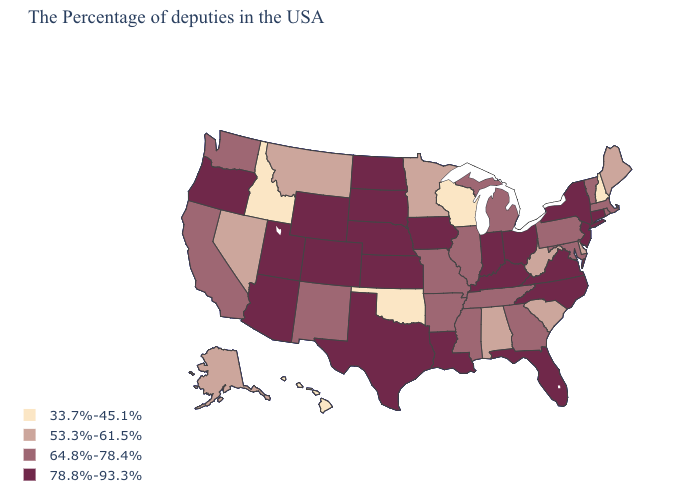Does the map have missing data?
Be succinct. No. Which states have the lowest value in the Northeast?
Write a very short answer. New Hampshire. What is the value of Alabama?
Keep it brief. 53.3%-61.5%. Which states hav the highest value in the South?
Write a very short answer. Virginia, North Carolina, Florida, Kentucky, Louisiana, Texas. Name the states that have a value in the range 78.8%-93.3%?
Answer briefly. Connecticut, New York, New Jersey, Virginia, North Carolina, Ohio, Florida, Kentucky, Indiana, Louisiana, Iowa, Kansas, Nebraska, Texas, South Dakota, North Dakota, Wyoming, Colorado, Utah, Arizona, Oregon. What is the value of Rhode Island?
Answer briefly. 64.8%-78.4%. Is the legend a continuous bar?
Be succinct. No. What is the value of New Hampshire?
Keep it brief. 33.7%-45.1%. Among the states that border Pennsylvania , does Delaware have the highest value?
Be succinct. No. Does the map have missing data?
Keep it brief. No. Does Maryland have a higher value than New Hampshire?
Be succinct. Yes. Name the states that have a value in the range 53.3%-61.5%?
Concise answer only. Maine, Delaware, South Carolina, West Virginia, Alabama, Minnesota, Montana, Nevada, Alaska. How many symbols are there in the legend?
Give a very brief answer. 4. Which states have the highest value in the USA?
Short answer required. Connecticut, New York, New Jersey, Virginia, North Carolina, Ohio, Florida, Kentucky, Indiana, Louisiana, Iowa, Kansas, Nebraska, Texas, South Dakota, North Dakota, Wyoming, Colorado, Utah, Arizona, Oregon. Name the states that have a value in the range 53.3%-61.5%?
Quick response, please. Maine, Delaware, South Carolina, West Virginia, Alabama, Minnesota, Montana, Nevada, Alaska. 